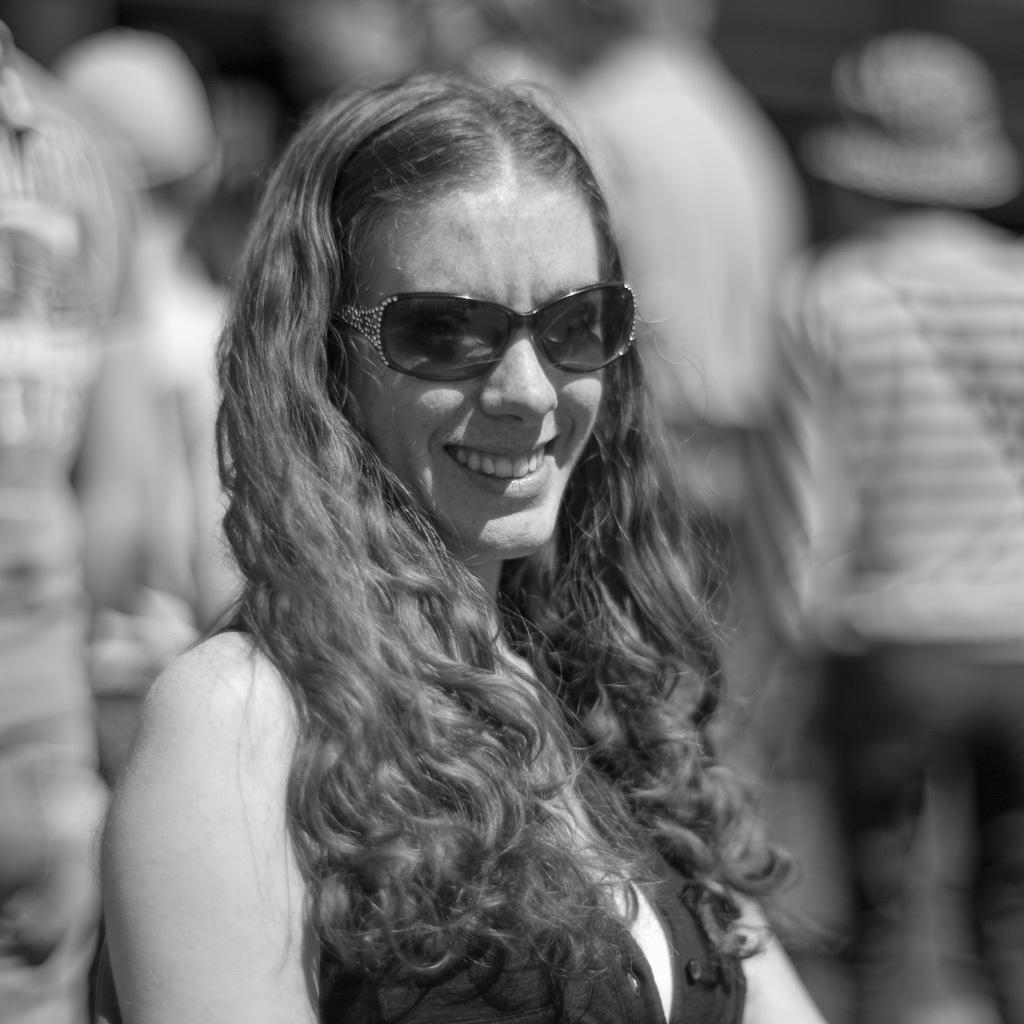What is the color scheme of the image? The image is black and white. Who is the main subject in the image? There is a woman in the middle of the image. What is the woman doing in the image? The woman is smiling. Can you describe the background of the image? The background of the image is blurred. How many people are visible in the image? There are people visible in the image. How many cows are visible in the image? There are no cows present in the image. What type of quilt is being used by the woman in the image? There is no quilt visible in the image. 